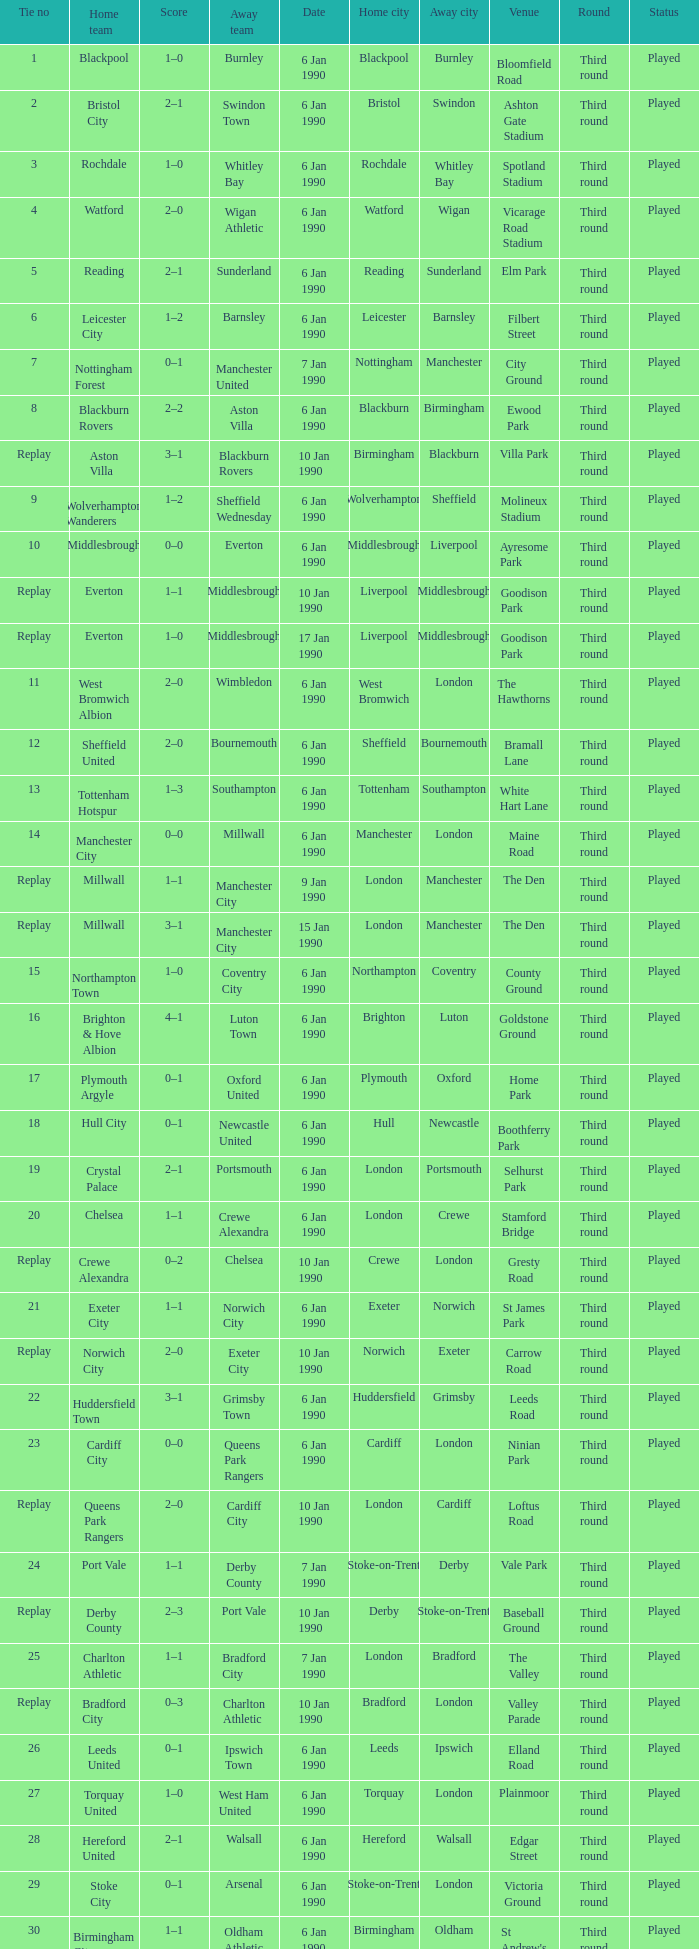What was the score of the game against away team crewe alexandra? 1–1. 